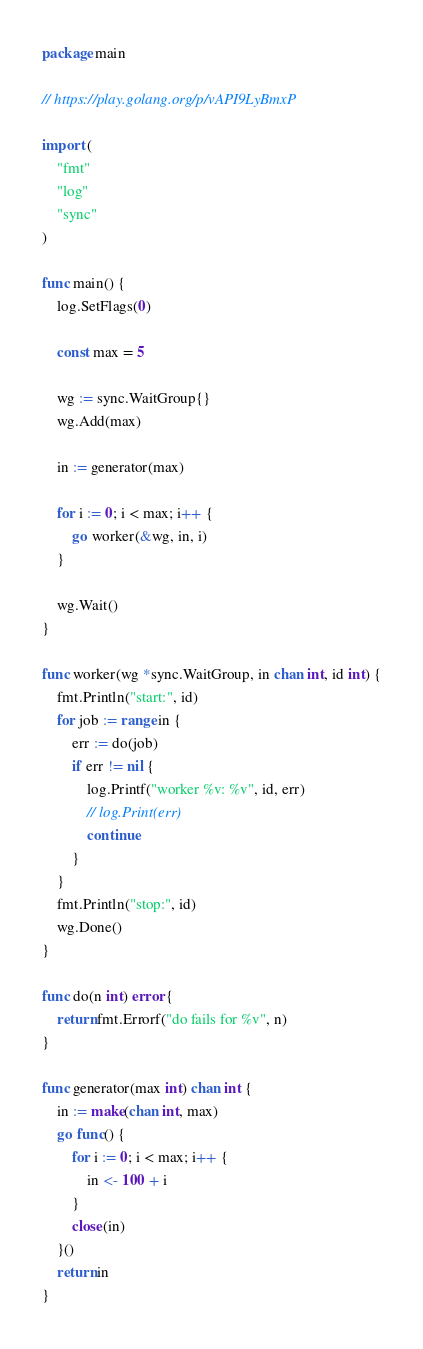Convert code to text. <code><loc_0><loc_0><loc_500><loc_500><_Go_>package main

// https://play.golang.org/p/vAPI9LyBmxP

import (
	"fmt"
	"log"
	"sync"
)

func main() {
	log.SetFlags(0)

	const max = 5

	wg := sync.WaitGroup{}
	wg.Add(max)

	in := generator(max)

	for i := 0; i < max; i++ {
		go worker(&wg, in, i)
	}

	wg.Wait()
}

func worker(wg *sync.WaitGroup, in chan int, id int) {
	fmt.Println("start:", id)
	for job := range in {
		err := do(job)
		if err != nil {
			log.Printf("worker %v: %v", id, err)
			// log.Print(err)
			continue
		}
	}
	fmt.Println("stop:", id)
	wg.Done()
}

func do(n int) error {
	return fmt.Errorf("do fails for %v", n)
}

func generator(max int) chan int {
	in := make(chan int, max)
	go func() {
		for i := 0; i < max; i++ {
			in <- 100 + i
		}
		close(in)
	}()
	return in
}
</code> 